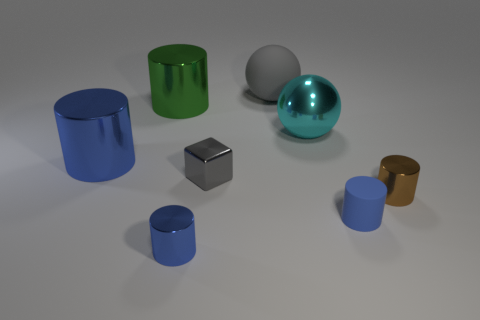Subtract all yellow cubes. How many blue cylinders are left? 3 Subtract 2 cylinders. How many cylinders are left? 3 Subtract all green cylinders. How many cylinders are left? 4 Subtract all blue matte cylinders. How many cylinders are left? 4 Subtract all purple cylinders. Subtract all purple spheres. How many cylinders are left? 5 Add 1 small gray metal spheres. How many objects exist? 9 Subtract all cylinders. How many objects are left? 3 Subtract all small blue metallic cylinders. Subtract all cyan spheres. How many objects are left? 6 Add 4 gray rubber objects. How many gray rubber objects are left? 5 Add 7 gray matte things. How many gray matte things exist? 8 